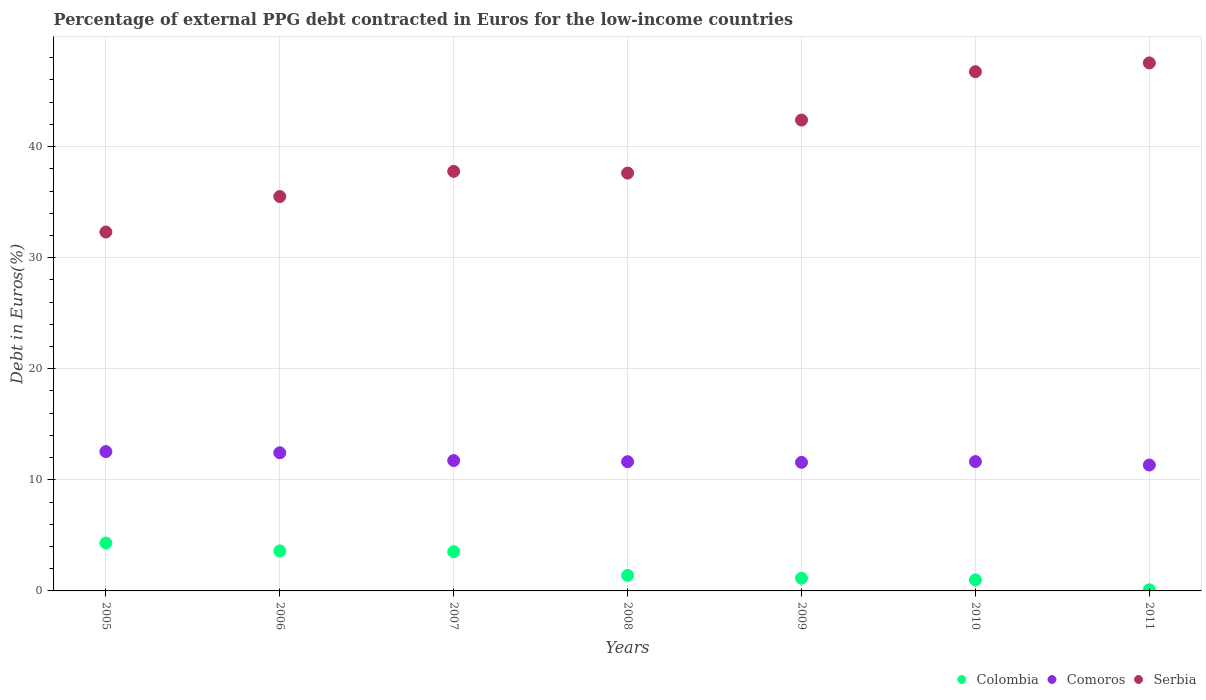How many different coloured dotlines are there?
Your answer should be very brief. 3. Is the number of dotlines equal to the number of legend labels?
Your response must be concise. Yes. What is the percentage of external PPG debt contracted in Euros in Comoros in 2008?
Keep it short and to the point. 11.63. Across all years, what is the maximum percentage of external PPG debt contracted in Euros in Colombia?
Offer a very short reply. 4.31. Across all years, what is the minimum percentage of external PPG debt contracted in Euros in Comoros?
Offer a terse response. 11.33. In which year was the percentage of external PPG debt contracted in Euros in Comoros maximum?
Offer a very short reply. 2005. In which year was the percentage of external PPG debt contracted in Euros in Serbia minimum?
Ensure brevity in your answer.  2005. What is the total percentage of external PPG debt contracted in Euros in Comoros in the graph?
Give a very brief answer. 82.9. What is the difference between the percentage of external PPG debt contracted in Euros in Comoros in 2008 and that in 2010?
Your answer should be compact. -0.01. What is the difference between the percentage of external PPG debt contracted in Euros in Serbia in 2010 and the percentage of external PPG debt contracted in Euros in Colombia in 2008?
Keep it short and to the point. 45.34. What is the average percentage of external PPG debt contracted in Euros in Comoros per year?
Your answer should be very brief. 11.84. In the year 2006, what is the difference between the percentage of external PPG debt contracted in Euros in Comoros and percentage of external PPG debt contracted in Euros in Serbia?
Offer a terse response. -23.07. In how many years, is the percentage of external PPG debt contracted in Euros in Colombia greater than 16 %?
Make the answer very short. 0. What is the ratio of the percentage of external PPG debt contracted in Euros in Comoros in 2006 to that in 2007?
Your response must be concise. 1.06. What is the difference between the highest and the second highest percentage of external PPG debt contracted in Euros in Serbia?
Your response must be concise. 0.79. What is the difference between the highest and the lowest percentage of external PPG debt contracted in Euros in Serbia?
Provide a succinct answer. 15.22. Is the sum of the percentage of external PPG debt contracted in Euros in Colombia in 2005 and 2007 greater than the maximum percentage of external PPG debt contracted in Euros in Serbia across all years?
Provide a succinct answer. No. Is it the case that in every year, the sum of the percentage of external PPG debt contracted in Euros in Comoros and percentage of external PPG debt contracted in Euros in Serbia  is greater than the percentage of external PPG debt contracted in Euros in Colombia?
Provide a succinct answer. Yes. Does the percentage of external PPG debt contracted in Euros in Comoros monotonically increase over the years?
Your response must be concise. No. Is the percentage of external PPG debt contracted in Euros in Comoros strictly greater than the percentage of external PPG debt contracted in Euros in Colombia over the years?
Give a very brief answer. Yes. Is the percentage of external PPG debt contracted in Euros in Serbia strictly less than the percentage of external PPG debt contracted in Euros in Comoros over the years?
Your answer should be very brief. No. How many dotlines are there?
Keep it short and to the point. 3. Does the graph contain any zero values?
Your response must be concise. No. Where does the legend appear in the graph?
Make the answer very short. Bottom right. How many legend labels are there?
Your response must be concise. 3. What is the title of the graph?
Offer a terse response. Percentage of external PPG debt contracted in Euros for the low-income countries. Does "Sao Tome and Principe" appear as one of the legend labels in the graph?
Your response must be concise. No. What is the label or title of the Y-axis?
Provide a short and direct response. Debt in Euros(%). What is the Debt in Euros(%) of Colombia in 2005?
Offer a very short reply. 4.31. What is the Debt in Euros(%) in Comoros in 2005?
Offer a terse response. 12.54. What is the Debt in Euros(%) in Serbia in 2005?
Keep it short and to the point. 32.31. What is the Debt in Euros(%) in Colombia in 2006?
Make the answer very short. 3.6. What is the Debt in Euros(%) of Comoros in 2006?
Provide a short and direct response. 12.44. What is the Debt in Euros(%) in Serbia in 2006?
Keep it short and to the point. 35.5. What is the Debt in Euros(%) of Colombia in 2007?
Keep it short and to the point. 3.53. What is the Debt in Euros(%) in Comoros in 2007?
Give a very brief answer. 11.73. What is the Debt in Euros(%) in Serbia in 2007?
Your answer should be compact. 37.77. What is the Debt in Euros(%) in Colombia in 2008?
Provide a short and direct response. 1.4. What is the Debt in Euros(%) in Comoros in 2008?
Offer a very short reply. 11.63. What is the Debt in Euros(%) of Serbia in 2008?
Your answer should be compact. 37.62. What is the Debt in Euros(%) in Colombia in 2009?
Your response must be concise. 1.14. What is the Debt in Euros(%) in Comoros in 2009?
Your answer should be compact. 11.57. What is the Debt in Euros(%) in Serbia in 2009?
Make the answer very short. 42.39. What is the Debt in Euros(%) of Colombia in 2010?
Your answer should be very brief. 0.99. What is the Debt in Euros(%) in Comoros in 2010?
Give a very brief answer. 11.65. What is the Debt in Euros(%) in Serbia in 2010?
Ensure brevity in your answer.  46.74. What is the Debt in Euros(%) of Colombia in 2011?
Ensure brevity in your answer.  0.1. What is the Debt in Euros(%) of Comoros in 2011?
Give a very brief answer. 11.33. What is the Debt in Euros(%) of Serbia in 2011?
Give a very brief answer. 47.53. Across all years, what is the maximum Debt in Euros(%) of Colombia?
Keep it short and to the point. 4.31. Across all years, what is the maximum Debt in Euros(%) in Comoros?
Your answer should be compact. 12.54. Across all years, what is the maximum Debt in Euros(%) of Serbia?
Offer a very short reply. 47.53. Across all years, what is the minimum Debt in Euros(%) in Colombia?
Your answer should be very brief. 0.1. Across all years, what is the minimum Debt in Euros(%) of Comoros?
Keep it short and to the point. 11.33. Across all years, what is the minimum Debt in Euros(%) of Serbia?
Make the answer very short. 32.31. What is the total Debt in Euros(%) in Colombia in the graph?
Your response must be concise. 15.08. What is the total Debt in Euros(%) of Comoros in the graph?
Give a very brief answer. 82.9. What is the total Debt in Euros(%) in Serbia in the graph?
Provide a short and direct response. 279.87. What is the difference between the Debt in Euros(%) in Colombia in 2005 and that in 2006?
Your response must be concise. 0.71. What is the difference between the Debt in Euros(%) of Comoros in 2005 and that in 2006?
Offer a terse response. 0.1. What is the difference between the Debt in Euros(%) of Serbia in 2005 and that in 2006?
Keep it short and to the point. -3.19. What is the difference between the Debt in Euros(%) in Colombia in 2005 and that in 2007?
Make the answer very short. 0.78. What is the difference between the Debt in Euros(%) of Comoros in 2005 and that in 2007?
Offer a terse response. 0.81. What is the difference between the Debt in Euros(%) of Serbia in 2005 and that in 2007?
Make the answer very short. -5.46. What is the difference between the Debt in Euros(%) of Colombia in 2005 and that in 2008?
Make the answer very short. 2.91. What is the difference between the Debt in Euros(%) of Comoros in 2005 and that in 2008?
Give a very brief answer. 0.91. What is the difference between the Debt in Euros(%) of Serbia in 2005 and that in 2008?
Make the answer very short. -5.31. What is the difference between the Debt in Euros(%) of Colombia in 2005 and that in 2009?
Provide a short and direct response. 3.17. What is the difference between the Debt in Euros(%) in Comoros in 2005 and that in 2009?
Make the answer very short. 0.97. What is the difference between the Debt in Euros(%) of Serbia in 2005 and that in 2009?
Offer a very short reply. -10.08. What is the difference between the Debt in Euros(%) in Colombia in 2005 and that in 2010?
Your answer should be compact. 3.32. What is the difference between the Debt in Euros(%) in Comoros in 2005 and that in 2010?
Give a very brief answer. 0.9. What is the difference between the Debt in Euros(%) in Serbia in 2005 and that in 2010?
Keep it short and to the point. -14.43. What is the difference between the Debt in Euros(%) of Colombia in 2005 and that in 2011?
Provide a succinct answer. 4.21. What is the difference between the Debt in Euros(%) in Comoros in 2005 and that in 2011?
Make the answer very short. 1.21. What is the difference between the Debt in Euros(%) of Serbia in 2005 and that in 2011?
Your answer should be very brief. -15.22. What is the difference between the Debt in Euros(%) in Colombia in 2006 and that in 2007?
Your answer should be very brief. 0.07. What is the difference between the Debt in Euros(%) in Comoros in 2006 and that in 2007?
Your answer should be compact. 0.7. What is the difference between the Debt in Euros(%) of Serbia in 2006 and that in 2007?
Give a very brief answer. -2.27. What is the difference between the Debt in Euros(%) in Colombia in 2006 and that in 2008?
Offer a terse response. 2.2. What is the difference between the Debt in Euros(%) of Comoros in 2006 and that in 2008?
Your answer should be very brief. 0.81. What is the difference between the Debt in Euros(%) in Serbia in 2006 and that in 2008?
Provide a succinct answer. -2.11. What is the difference between the Debt in Euros(%) of Colombia in 2006 and that in 2009?
Your answer should be very brief. 2.46. What is the difference between the Debt in Euros(%) in Comoros in 2006 and that in 2009?
Your answer should be compact. 0.87. What is the difference between the Debt in Euros(%) in Serbia in 2006 and that in 2009?
Your response must be concise. -6.88. What is the difference between the Debt in Euros(%) in Colombia in 2006 and that in 2010?
Give a very brief answer. 2.61. What is the difference between the Debt in Euros(%) in Comoros in 2006 and that in 2010?
Keep it short and to the point. 0.79. What is the difference between the Debt in Euros(%) in Serbia in 2006 and that in 2010?
Give a very brief answer. -11.24. What is the difference between the Debt in Euros(%) of Colombia in 2006 and that in 2011?
Your answer should be very brief. 3.5. What is the difference between the Debt in Euros(%) of Comoros in 2006 and that in 2011?
Offer a terse response. 1.1. What is the difference between the Debt in Euros(%) of Serbia in 2006 and that in 2011?
Your response must be concise. -12.03. What is the difference between the Debt in Euros(%) of Colombia in 2007 and that in 2008?
Provide a short and direct response. 2.13. What is the difference between the Debt in Euros(%) in Comoros in 2007 and that in 2008?
Ensure brevity in your answer.  0.1. What is the difference between the Debt in Euros(%) in Serbia in 2007 and that in 2008?
Ensure brevity in your answer.  0.15. What is the difference between the Debt in Euros(%) of Colombia in 2007 and that in 2009?
Offer a terse response. 2.39. What is the difference between the Debt in Euros(%) in Comoros in 2007 and that in 2009?
Make the answer very short. 0.16. What is the difference between the Debt in Euros(%) in Serbia in 2007 and that in 2009?
Your response must be concise. -4.62. What is the difference between the Debt in Euros(%) in Colombia in 2007 and that in 2010?
Give a very brief answer. 2.54. What is the difference between the Debt in Euros(%) in Comoros in 2007 and that in 2010?
Ensure brevity in your answer.  0.09. What is the difference between the Debt in Euros(%) in Serbia in 2007 and that in 2010?
Your answer should be very brief. -8.97. What is the difference between the Debt in Euros(%) of Colombia in 2007 and that in 2011?
Make the answer very short. 3.43. What is the difference between the Debt in Euros(%) in Comoros in 2007 and that in 2011?
Your answer should be very brief. 0.4. What is the difference between the Debt in Euros(%) in Serbia in 2007 and that in 2011?
Your answer should be compact. -9.76. What is the difference between the Debt in Euros(%) in Colombia in 2008 and that in 2009?
Ensure brevity in your answer.  0.25. What is the difference between the Debt in Euros(%) of Comoros in 2008 and that in 2009?
Provide a short and direct response. 0.06. What is the difference between the Debt in Euros(%) of Serbia in 2008 and that in 2009?
Offer a terse response. -4.77. What is the difference between the Debt in Euros(%) of Colombia in 2008 and that in 2010?
Give a very brief answer. 0.41. What is the difference between the Debt in Euros(%) of Comoros in 2008 and that in 2010?
Offer a very short reply. -0.01. What is the difference between the Debt in Euros(%) of Serbia in 2008 and that in 2010?
Your answer should be very brief. -9.13. What is the difference between the Debt in Euros(%) in Colombia in 2008 and that in 2011?
Your answer should be very brief. 1.3. What is the difference between the Debt in Euros(%) of Comoros in 2008 and that in 2011?
Your answer should be compact. 0.3. What is the difference between the Debt in Euros(%) of Serbia in 2008 and that in 2011?
Provide a short and direct response. -9.92. What is the difference between the Debt in Euros(%) in Colombia in 2009 and that in 2010?
Provide a succinct answer. 0.15. What is the difference between the Debt in Euros(%) in Comoros in 2009 and that in 2010?
Keep it short and to the point. -0.07. What is the difference between the Debt in Euros(%) in Serbia in 2009 and that in 2010?
Make the answer very short. -4.35. What is the difference between the Debt in Euros(%) in Colombia in 2009 and that in 2011?
Make the answer very short. 1.04. What is the difference between the Debt in Euros(%) of Comoros in 2009 and that in 2011?
Keep it short and to the point. 0.24. What is the difference between the Debt in Euros(%) of Serbia in 2009 and that in 2011?
Your answer should be very brief. -5.14. What is the difference between the Debt in Euros(%) of Colombia in 2010 and that in 2011?
Offer a terse response. 0.89. What is the difference between the Debt in Euros(%) of Comoros in 2010 and that in 2011?
Provide a short and direct response. 0.31. What is the difference between the Debt in Euros(%) of Serbia in 2010 and that in 2011?
Give a very brief answer. -0.79. What is the difference between the Debt in Euros(%) in Colombia in 2005 and the Debt in Euros(%) in Comoros in 2006?
Provide a succinct answer. -8.12. What is the difference between the Debt in Euros(%) in Colombia in 2005 and the Debt in Euros(%) in Serbia in 2006?
Your response must be concise. -31.19. What is the difference between the Debt in Euros(%) in Comoros in 2005 and the Debt in Euros(%) in Serbia in 2006?
Make the answer very short. -22.96. What is the difference between the Debt in Euros(%) of Colombia in 2005 and the Debt in Euros(%) of Comoros in 2007?
Provide a succinct answer. -7.42. What is the difference between the Debt in Euros(%) in Colombia in 2005 and the Debt in Euros(%) in Serbia in 2007?
Offer a very short reply. -33.46. What is the difference between the Debt in Euros(%) in Comoros in 2005 and the Debt in Euros(%) in Serbia in 2007?
Provide a short and direct response. -25.23. What is the difference between the Debt in Euros(%) of Colombia in 2005 and the Debt in Euros(%) of Comoros in 2008?
Ensure brevity in your answer.  -7.32. What is the difference between the Debt in Euros(%) of Colombia in 2005 and the Debt in Euros(%) of Serbia in 2008?
Offer a terse response. -33.3. What is the difference between the Debt in Euros(%) in Comoros in 2005 and the Debt in Euros(%) in Serbia in 2008?
Offer a very short reply. -25.07. What is the difference between the Debt in Euros(%) of Colombia in 2005 and the Debt in Euros(%) of Comoros in 2009?
Your answer should be compact. -7.26. What is the difference between the Debt in Euros(%) in Colombia in 2005 and the Debt in Euros(%) in Serbia in 2009?
Offer a very short reply. -38.08. What is the difference between the Debt in Euros(%) of Comoros in 2005 and the Debt in Euros(%) of Serbia in 2009?
Your answer should be very brief. -29.85. What is the difference between the Debt in Euros(%) in Colombia in 2005 and the Debt in Euros(%) in Comoros in 2010?
Give a very brief answer. -7.33. What is the difference between the Debt in Euros(%) of Colombia in 2005 and the Debt in Euros(%) of Serbia in 2010?
Give a very brief answer. -42.43. What is the difference between the Debt in Euros(%) of Comoros in 2005 and the Debt in Euros(%) of Serbia in 2010?
Offer a very short reply. -34.2. What is the difference between the Debt in Euros(%) of Colombia in 2005 and the Debt in Euros(%) of Comoros in 2011?
Your answer should be very brief. -7.02. What is the difference between the Debt in Euros(%) of Colombia in 2005 and the Debt in Euros(%) of Serbia in 2011?
Offer a very short reply. -43.22. What is the difference between the Debt in Euros(%) of Comoros in 2005 and the Debt in Euros(%) of Serbia in 2011?
Ensure brevity in your answer.  -34.99. What is the difference between the Debt in Euros(%) in Colombia in 2006 and the Debt in Euros(%) in Comoros in 2007?
Give a very brief answer. -8.13. What is the difference between the Debt in Euros(%) in Colombia in 2006 and the Debt in Euros(%) in Serbia in 2007?
Provide a short and direct response. -34.17. What is the difference between the Debt in Euros(%) of Comoros in 2006 and the Debt in Euros(%) of Serbia in 2007?
Offer a terse response. -25.33. What is the difference between the Debt in Euros(%) of Colombia in 2006 and the Debt in Euros(%) of Comoros in 2008?
Keep it short and to the point. -8.03. What is the difference between the Debt in Euros(%) of Colombia in 2006 and the Debt in Euros(%) of Serbia in 2008?
Your response must be concise. -34.01. What is the difference between the Debt in Euros(%) of Comoros in 2006 and the Debt in Euros(%) of Serbia in 2008?
Make the answer very short. -25.18. What is the difference between the Debt in Euros(%) in Colombia in 2006 and the Debt in Euros(%) in Comoros in 2009?
Keep it short and to the point. -7.97. What is the difference between the Debt in Euros(%) in Colombia in 2006 and the Debt in Euros(%) in Serbia in 2009?
Your answer should be compact. -38.79. What is the difference between the Debt in Euros(%) of Comoros in 2006 and the Debt in Euros(%) of Serbia in 2009?
Make the answer very short. -29.95. What is the difference between the Debt in Euros(%) in Colombia in 2006 and the Debt in Euros(%) in Comoros in 2010?
Your answer should be very brief. -8.04. What is the difference between the Debt in Euros(%) of Colombia in 2006 and the Debt in Euros(%) of Serbia in 2010?
Provide a short and direct response. -43.14. What is the difference between the Debt in Euros(%) of Comoros in 2006 and the Debt in Euros(%) of Serbia in 2010?
Keep it short and to the point. -34.31. What is the difference between the Debt in Euros(%) in Colombia in 2006 and the Debt in Euros(%) in Comoros in 2011?
Your answer should be compact. -7.73. What is the difference between the Debt in Euros(%) in Colombia in 2006 and the Debt in Euros(%) in Serbia in 2011?
Provide a succinct answer. -43.93. What is the difference between the Debt in Euros(%) in Comoros in 2006 and the Debt in Euros(%) in Serbia in 2011?
Your response must be concise. -35.1. What is the difference between the Debt in Euros(%) of Colombia in 2007 and the Debt in Euros(%) of Comoros in 2008?
Your answer should be compact. -8.1. What is the difference between the Debt in Euros(%) of Colombia in 2007 and the Debt in Euros(%) of Serbia in 2008?
Provide a succinct answer. -34.09. What is the difference between the Debt in Euros(%) of Comoros in 2007 and the Debt in Euros(%) of Serbia in 2008?
Your response must be concise. -25.88. What is the difference between the Debt in Euros(%) of Colombia in 2007 and the Debt in Euros(%) of Comoros in 2009?
Your answer should be very brief. -8.04. What is the difference between the Debt in Euros(%) of Colombia in 2007 and the Debt in Euros(%) of Serbia in 2009?
Offer a terse response. -38.86. What is the difference between the Debt in Euros(%) in Comoros in 2007 and the Debt in Euros(%) in Serbia in 2009?
Give a very brief answer. -30.66. What is the difference between the Debt in Euros(%) in Colombia in 2007 and the Debt in Euros(%) in Comoros in 2010?
Offer a very short reply. -8.12. What is the difference between the Debt in Euros(%) of Colombia in 2007 and the Debt in Euros(%) of Serbia in 2010?
Provide a succinct answer. -43.21. What is the difference between the Debt in Euros(%) in Comoros in 2007 and the Debt in Euros(%) in Serbia in 2010?
Provide a short and direct response. -35.01. What is the difference between the Debt in Euros(%) of Colombia in 2007 and the Debt in Euros(%) of Comoros in 2011?
Make the answer very short. -7.8. What is the difference between the Debt in Euros(%) of Colombia in 2007 and the Debt in Euros(%) of Serbia in 2011?
Offer a very short reply. -44. What is the difference between the Debt in Euros(%) in Comoros in 2007 and the Debt in Euros(%) in Serbia in 2011?
Ensure brevity in your answer.  -35.8. What is the difference between the Debt in Euros(%) in Colombia in 2008 and the Debt in Euros(%) in Comoros in 2009?
Provide a short and direct response. -10.17. What is the difference between the Debt in Euros(%) of Colombia in 2008 and the Debt in Euros(%) of Serbia in 2009?
Offer a very short reply. -40.99. What is the difference between the Debt in Euros(%) in Comoros in 2008 and the Debt in Euros(%) in Serbia in 2009?
Offer a terse response. -30.76. What is the difference between the Debt in Euros(%) in Colombia in 2008 and the Debt in Euros(%) in Comoros in 2010?
Offer a very short reply. -10.25. What is the difference between the Debt in Euros(%) of Colombia in 2008 and the Debt in Euros(%) of Serbia in 2010?
Offer a terse response. -45.34. What is the difference between the Debt in Euros(%) of Comoros in 2008 and the Debt in Euros(%) of Serbia in 2010?
Your answer should be compact. -35.11. What is the difference between the Debt in Euros(%) in Colombia in 2008 and the Debt in Euros(%) in Comoros in 2011?
Your answer should be very brief. -9.94. What is the difference between the Debt in Euros(%) of Colombia in 2008 and the Debt in Euros(%) of Serbia in 2011?
Offer a very short reply. -46.13. What is the difference between the Debt in Euros(%) in Comoros in 2008 and the Debt in Euros(%) in Serbia in 2011?
Offer a very short reply. -35.9. What is the difference between the Debt in Euros(%) in Colombia in 2009 and the Debt in Euros(%) in Comoros in 2010?
Provide a short and direct response. -10.5. What is the difference between the Debt in Euros(%) in Colombia in 2009 and the Debt in Euros(%) in Serbia in 2010?
Offer a terse response. -45.6. What is the difference between the Debt in Euros(%) of Comoros in 2009 and the Debt in Euros(%) of Serbia in 2010?
Provide a succinct answer. -35.17. What is the difference between the Debt in Euros(%) of Colombia in 2009 and the Debt in Euros(%) of Comoros in 2011?
Offer a terse response. -10.19. What is the difference between the Debt in Euros(%) in Colombia in 2009 and the Debt in Euros(%) in Serbia in 2011?
Your response must be concise. -46.39. What is the difference between the Debt in Euros(%) in Comoros in 2009 and the Debt in Euros(%) in Serbia in 2011?
Keep it short and to the point. -35.96. What is the difference between the Debt in Euros(%) in Colombia in 2010 and the Debt in Euros(%) in Comoros in 2011?
Offer a terse response. -10.34. What is the difference between the Debt in Euros(%) of Colombia in 2010 and the Debt in Euros(%) of Serbia in 2011?
Your answer should be compact. -46.54. What is the difference between the Debt in Euros(%) of Comoros in 2010 and the Debt in Euros(%) of Serbia in 2011?
Make the answer very short. -35.89. What is the average Debt in Euros(%) of Colombia per year?
Offer a terse response. 2.15. What is the average Debt in Euros(%) of Comoros per year?
Give a very brief answer. 11.84. What is the average Debt in Euros(%) of Serbia per year?
Provide a succinct answer. 39.98. In the year 2005, what is the difference between the Debt in Euros(%) in Colombia and Debt in Euros(%) in Comoros?
Keep it short and to the point. -8.23. In the year 2005, what is the difference between the Debt in Euros(%) of Colombia and Debt in Euros(%) of Serbia?
Offer a very short reply. -28. In the year 2005, what is the difference between the Debt in Euros(%) in Comoros and Debt in Euros(%) in Serbia?
Make the answer very short. -19.77. In the year 2006, what is the difference between the Debt in Euros(%) in Colombia and Debt in Euros(%) in Comoros?
Keep it short and to the point. -8.83. In the year 2006, what is the difference between the Debt in Euros(%) in Colombia and Debt in Euros(%) in Serbia?
Offer a very short reply. -31.9. In the year 2006, what is the difference between the Debt in Euros(%) of Comoros and Debt in Euros(%) of Serbia?
Give a very brief answer. -23.07. In the year 2007, what is the difference between the Debt in Euros(%) of Colombia and Debt in Euros(%) of Comoros?
Keep it short and to the point. -8.2. In the year 2007, what is the difference between the Debt in Euros(%) of Colombia and Debt in Euros(%) of Serbia?
Offer a very short reply. -34.24. In the year 2007, what is the difference between the Debt in Euros(%) of Comoros and Debt in Euros(%) of Serbia?
Your answer should be compact. -26.04. In the year 2008, what is the difference between the Debt in Euros(%) in Colombia and Debt in Euros(%) in Comoros?
Your response must be concise. -10.23. In the year 2008, what is the difference between the Debt in Euros(%) in Colombia and Debt in Euros(%) in Serbia?
Give a very brief answer. -36.22. In the year 2008, what is the difference between the Debt in Euros(%) in Comoros and Debt in Euros(%) in Serbia?
Make the answer very short. -25.98. In the year 2009, what is the difference between the Debt in Euros(%) of Colombia and Debt in Euros(%) of Comoros?
Your answer should be very brief. -10.43. In the year 2009, what is the difference between the Debt in Euros(%) in Colombia and Debt in Euros(%) in Serbia?
Your answer should be compact. -41.24. In the year 2009, what is the difference between the Debt in Euros(%) in Comoros and Debt in Euros(%) in Serbia?
Offer a very short reply. -30.82. In the year 2010, what is the difference between the Debt in Euros(%) in Colombia and Debt in Euros(%) in Comoros?
Your answer should be compact. -10.66. In the year 2010, what is the difference between the Debt in Euros(%) in Colombia and Debt in Euros(%) in Serbia?
Offer a terse response. -45.75. In the year 2010, what is the difference between the Debt in Euros(%) of Comoros and Debt in Euros(%) of Serbia?
Make the answer very short. -35.1. In the year 2011, what is the difference between the Debt in Euros(%) in Colombia and Debt in Euros(%) in Comoros?
Provide a succinct answer. -11.23. In the year 2011, what is the difference between the Debt in Euros(%) in Colombia and Debt in Euros(%) in Serbia?
Make the answer very short. -47.43. In the year 2011, what is the difference between the Debt in Euros(%) in Comoros and Debt in Euros(%) in Serbia?
Make the answer very short. -36.2. What is the ratio of the Debt in Euros(%) in Colombia in 2005 to that in 2006?
Give a very brief answer. 1.2. What is the ratio of the Debt in Euros(%) in Comoros in 2005 to that in 2006?
Your answer should be very brief. 1.01. What is the ratio of the Debt in Euros(%) of Serbia in 2005 to that in 2006?
Offer a terse response. 0.91. What is the ratio of the Debt in Euros(%) in Colombia in 2005 to that in 2007?
Your answer should be very brief. 1.22. What is the ratio of the Debt in Euros(%) in Comoros in 2005 to that in 2007?
Offer a terse response. 1.07. What is the ratio of the Debt in Euros(%) of Serbia in 2005 to that in 2007?
Provide a short and direct response. 0.86. What is the ratio of the Debt in Euros(%) in Colombia in 2005 to that in 2008?
Your answer should be compact. 3.08. What is the ratio of the Debt in Euros(%) of Comoros in 2005 to that in 2008?
Provide a short and direct response. 1.08. What is the ratio of the Debt in Euros(%) of Serbia in 2005 to that in 2008?
Your answer should be very brief. 0.86. What is the ratio of the Debt in Euros(%) in Colombia in 2005 to that in 2009?
Your response must be concise. 3.77. What is the ratio of the Debt in Euros(%) of Comoros in 2005 to that in 2009?
Give a very brief answer. 1.08. What is the ratio of the Debt in Euros(%) in Serbia in 2005 to that in 2009?
Make the answer very short. 0.76. What is the ratio of the Debt in Euros(%) of Colombia in 2005 to that in 2010?
Provide a succinct answer. 4.36. What is the ratio of the Debt in Euros(%) in Comoros in 2005 to that in 2010?
Offer a very short reply. 1.08. What is the ratio of the Debt in Euros(%) of Serbia in 2005 to that in 2010?
Provide a succinct answer. 0.69. What is the ratio of the Debt in Euros(%) of Colombia in 2005 to that in 2011?
Your answer should be very brief. 42.75. What is the ratio of the Debt in Euros(%) in Comoros in 2005 to that in 2011?
Offer a terse response. 1.11. What is the ratio of the Debt in Euros(%) of Serbia in 2005 to that in 2011?
Offer a terse response. 0.68. What is the ratio of the Debt in Euros(%) of Colombia in 2006 to that in 2007?
Give a very brief answer. 1.02. What is the ratio of the Debt in Euros(%) in Comoros in 2006 to that in 2007?
Provide a succinct answer. 1.06. What is the ratio of the Debt in Euros(%) in Serbia in 2006 to that in 2007?
Give a very brief answer. 0.94. What is the ratio of the Debt in Euros(%) in Colombia in 2006 to that in 2008?
Give a very brief answer. 2.58. What is the ratio of the Debt in Euros(%) of Comoros in 2006 to that in 2008?
Provide a succinct answer. 1.07. What is the ratio of the Debt in Euros(%) of Serbia in 2006 to that in 2008?
Offer a very short reply. 0.94. What is the ratio of the Debt in Euros(%) of Colombia in 2006 to that in 2009?
Keep it short and to the point. 3.15. What is the ratio of the Debt in Euros(%) in Comoros in 2006 to that in 2009?
Your answer should be very brief. 1.07. What is the ratio of the Debt in Euros(%) in Serbia in 2006 to that in 2009?
Your answer should be compact. 0.84. What is the ratio of the Debt in Euros(%) in Colombia in 2006 to that in 2010?
Your answer should be compact. 3.64. What is the ratio of the Debt in Euros(%) of Comoros in 2006 to that in 2010?
Give a very brief answer. 1.07. What is the ratio of the Debt in Euros(%) of Serbia in 2006 to that in 2010?
Keep it short and to the point. 0.76. What is the ratio of the Debt in Euros(%) of Colombia in 2006 to that in 2011?
Keep it short and to the point. 35.71. What is the ratio of the Debt in Euros(%) of Comoros in 2006 to that in 2011?
Offer a very short reply. 1.1. What is the ratio of the Debt in Euros(%) in Serbia in 2006 to that in 2011?
Make the answer very short. 0.75. What is the ratio of the Debt in Euros(%) in Colombia in 2007 to that in 2008?
Your answer should be compact. 2.52. What is the ratio of the Debt in Euros(%) in Comoros in 2007 to that in 2008?
Offer a very short reply. 1.01. What is the ratio of the Debt in Euros(%) of Colombia in 2007 to that in 2009?
Your answer should be very brief. 3.08. What is the ratio of the Debt in Euros(%) of Comoros in 2007 to that in 2009?
Offer a very short reply. 1.01. What is the ratio of the Debt in Euros(%) in Serbia in 2007 to that in 2009?
Provide a short and direct response. 0.89. What is the ratio of the Debt in Euros(%) in Colombia in 2007 to that in 2010?
Make the answer very short. 3.57. What is the ratio of the Debt in Euros(%) of Comoros in 2007 to that in 2010?
Make the answer very short. 1.01. What is the ratio of the Debt in Euros(%) in Serbia in 2007 to that in 2010?
Make the answer very short. 0.81. What is the ratio of the Debt in Euros(%) of Colombia in 2007 to that in 2011?
Make the answer very short. 34.98. What is the ratio of the Debt in Euros(%) in Comoros in 2007 to that in 2011?
Offer a very short reply. 1.04. What is the ratio of the Debt in Euros(%) in Serbia in 2007 to that in 2011?
Make the answer very short. 0.79. What is the ratio of the Debt in Euros(%) of Colombia in 2008 to that in 2009?
Your response must be concise. 1.22. What is the ratio of the Debt in Euros(%) of Serbia in 2008 to that in 2009?
Your response must be concise. 0.89. What is the ratio of the Debt in Euros(%) of Colombia in 2008 to that in 2010?
Your answer should be very brief. 1.41. What is the ratio of the Debt in Euros(%) in Serbia in 2008 to that in 2010?
Ensure brevity in your answer.  0.8. What is the ratio of the Debt in Euros(%) in Colombia in 2008 to that in 2011?
Make the answer very short. 13.86. What is the ratio of the Debt in Euros(%) of Comoros in 2008 to that in 2011?
Keep it short and to the point. 1.03. What is the ratio of the Debt in Euros(%) in Serbia in 2008 to that in 2011?
Your response must be concise. 0.79. What is the ratio of the Debt in Euros(%) of Colombia in 2009 to that in 2010?
Your response must be concise. 1.16. What is the ratio of the Debt in Euros(%) of Serbia in 2009 to that in 2010?
Offer a terse response. 0.91. What is the ratio of the Debt in Euros(%) in Colombia in 2009 to that in 2011?
Offer a terse response. 11.34. What is the ratio of the Debt in Euros(%) of Comoros in 2009 to that in 2011?
Your answer should be compact. 1.02. What is the ratio of the Debt in Euros(%) of Serbia in 2009 to that in 2011?
Make the answer very short. 0.89. What is the ratio of the Debt in Euros(%) of Colombia in 2010 to that in 2011?
Make the answer very short. 9.81. What is the ratio of the Debt in Euros(%) in Comoros in 2010 to that in 2011?
Ensure brevity in your answer.  1.03. What is the ratio of the Debt in Euros(%) in Serbia in 2010 to that in 2011?
Make the answer very short. 0.98. What is the difference between the highest and the second highest Debt in Euros(%) of Colombia?
Your answer should be very brief. 0.71. What is the difference between the highest and the second highest Debt in Euros(%) of Comoros?
Ensure brevity in your answer.  0.1. What is the difference between the highest and the second highest Debt in Euros(%) in Serbia?
Offer a very short reply. 0.79. What is the difference between the highest and the lowest Debt in Euros(%) of Colombia?
Provide a short and direct response. 4.21. What is the difference between the highest and the lowest Debt in Euros(%) of Comoros?
Provide a succinct answer. 1.21. What is the difference between the highest and the lowest Debt in Euros(%) in Serbia?
Provide a succinct answer. 15.22. 